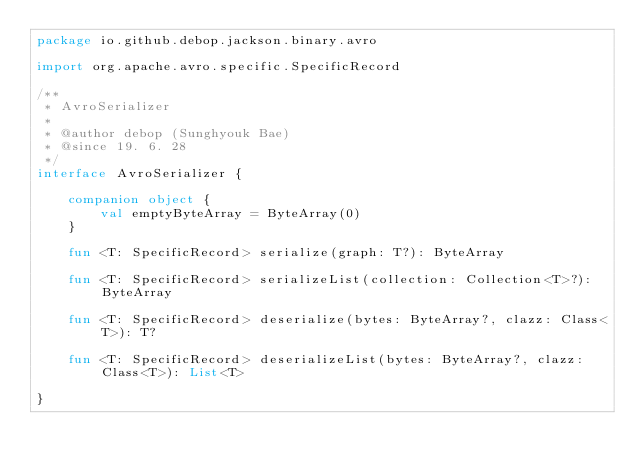Convert code to text. <code><loc_0><loc_0><loc_500><loc_500><_Kotlin_>package io.github.debop.jackson.binary.avro

import org.apache.avro.specific.SpecificRecord

/**
 * AvroSerializer
 *
 * @author debop (Sunghyouk Bae)
 * @since 19. 6. 28
 */
interface AvroSerializer {

    companion object {
        val emptyByteArray = ByteArray(0)
    }

    fun <T: SpecificRecord> serialize(graph: T?): ByteArray

    fun <T: SpecificRecord> serializeList(collection: Collection<T>?): ByteArray

    fun <T: SpecificRecord> deserialize(bytes: ByteArray?, clazz: Class<T>): T?

    fun <T: SpecificRecord> deserializeList(bytes: ByteArray?, clazz: Class<T>): List<T>

}</code> 